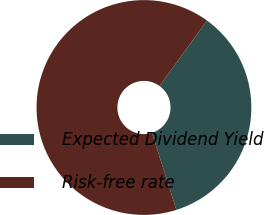Convert chart to OTSL. <chart><loc_0><loc_0><loc_500><loc_500><pie_chart><fcel>Expected Dividend Yield<fcel>Risk-free rate<nl><fcel>35.13%<fcel>64.87%<nl></chart> 